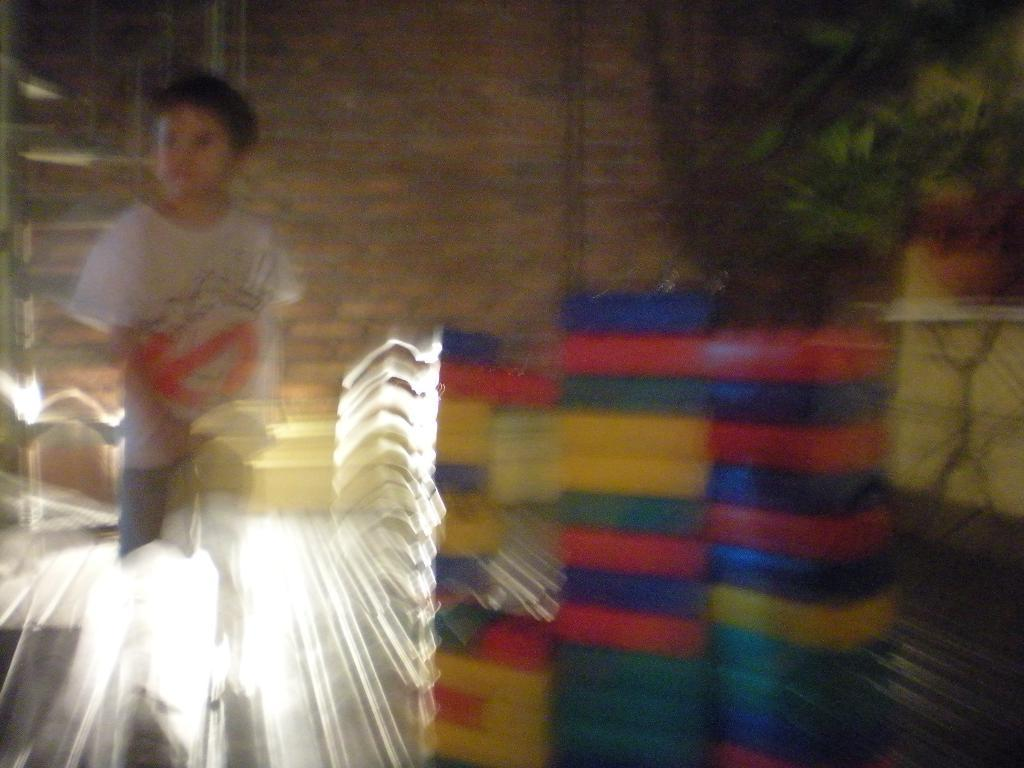What type of door is visible in the image? There is a glass door in the image. What can be seen in the glass door's reflection? The reflection includes a child, blocks, flower pots, and a wall. Can you describe the objects visible in the reflection? The child is playing with blocks, which are placed near flower pots, and there is a wall visible in the background. What type of meat is being served on the card in the image? There is no meat or card present in the image. 